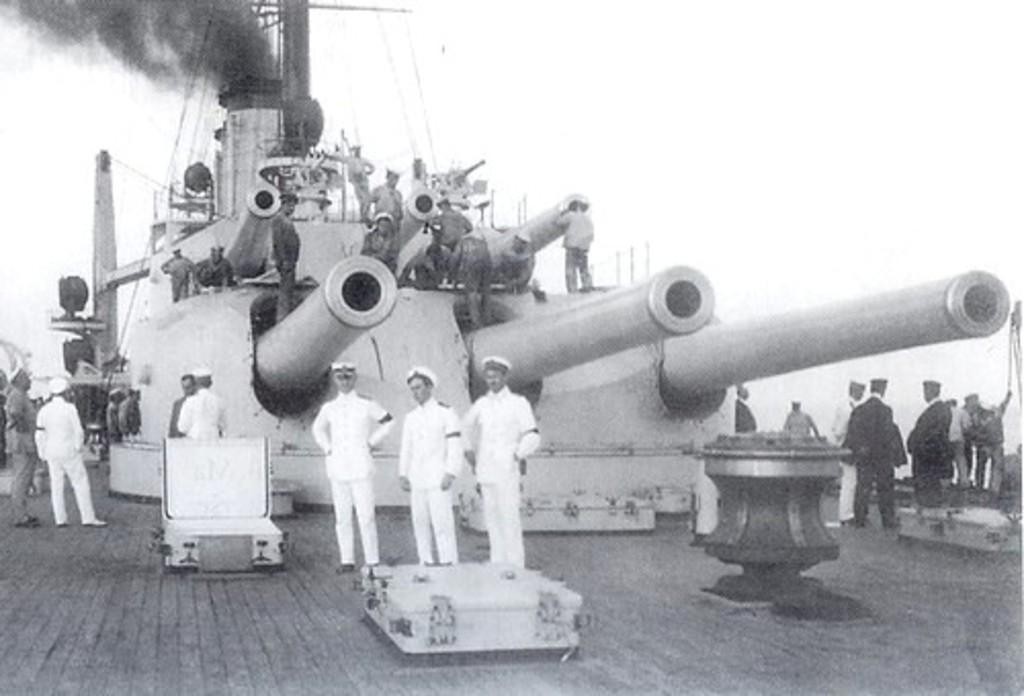What object in the image can be considered a weapon? There is a weapon in the image. What are the people doing in relation to the weapon? There are people standing on the weapon. What else can be seen in the image besides the weapon and people? There are wires visible in the image. What is the presence of smoke in the image indicative of? There is smoke in the image, which might suggest some sort of activity or event. Where are the other people in the image located? There are people standing on the floor in the image. How many trees can be seen in the image? There are no trees visible in the image. What type of nest is present in the image? There is no nest present in the image. 